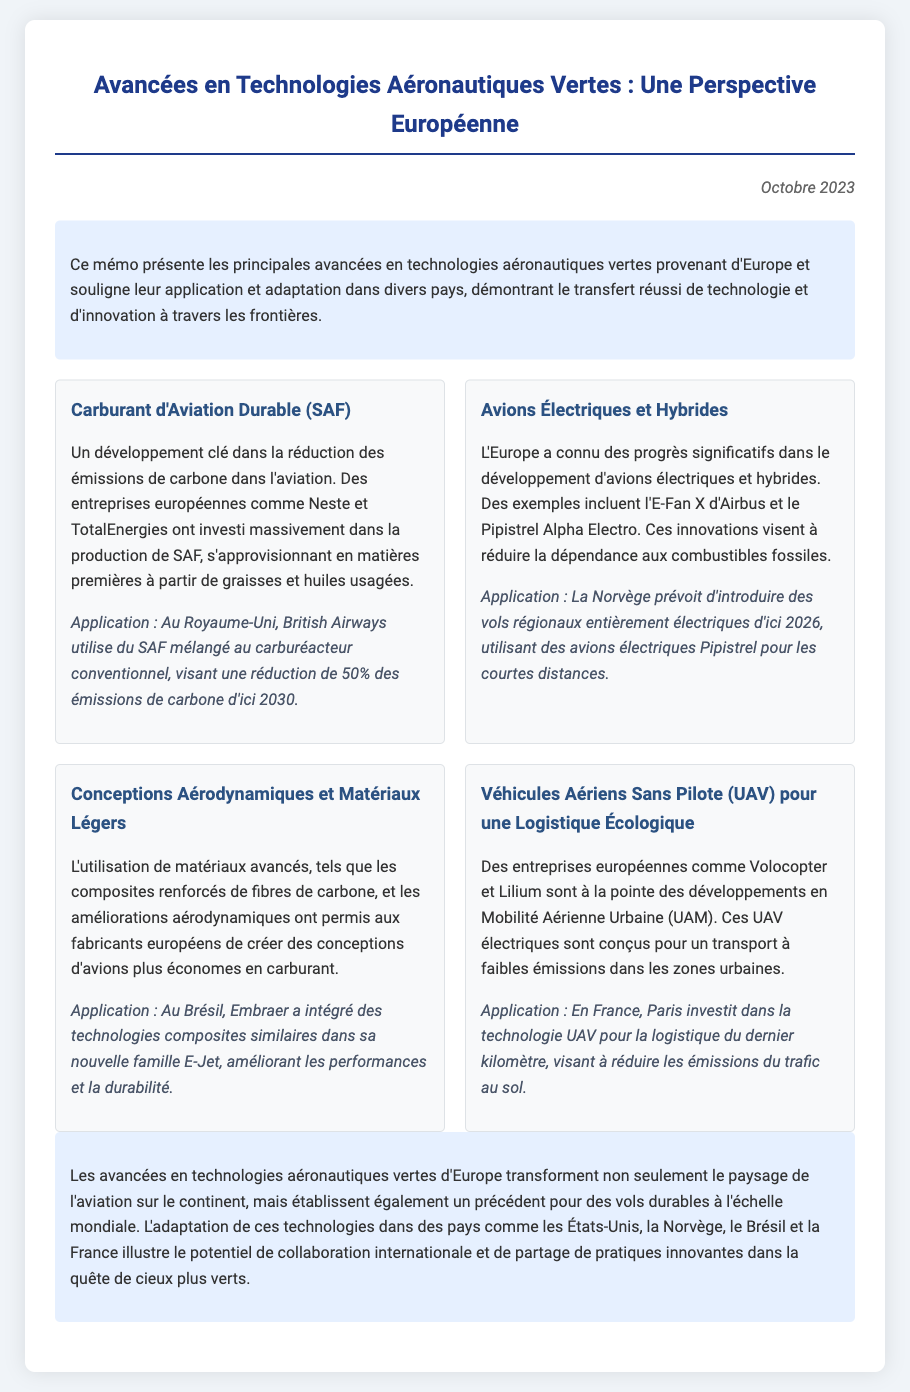Quel est le titre du mémo ? Le titre du mémo est mentionné en haut du document, et il est "Avancées en Technologies Aéronautiques Vertes : Une Perspective Européenne".
Answer: Avancées en Technologies Aéronautiques Vertes : Une Perspective Européenne Quelle entreprise européenne a investi dans la production de carburant d'aviation durable ? La production de carburant d'aviation durable implique des entreprises spécifiques européennes, telles que Neste et TotalEnergies.
Answer: Neste et TotalEnergies Quel est l'objectif de British Airways concernant les émissions de carbone d'ici 2030 ? L'objectif mentionné dans l'application du carburant d'aviation durable est de réduire de 50% les émissions de carbone d'ici 2030.
Answer: 50% Quel type d'avion la Norvège prévoit-elle d'introduire d'ici 2026 ? Le document indique que la Norvège prévoit d'introduire des vols régionaux entièrement électriques.
Answer: Vols régionaux entièrement électriques Comment la France utilise-t-elle la technologie UAV ? L'application de la technologie UAV en France vise à réduire les émissions du trafic au sol.
Answer: Réduire les émissions du trafic au sol Quels matériaux avancés sont mentionnés concernant les conceptions d'avions ? Le mémo évoque l'utilisation de composites renforcés de fibres de carbone comme matériaux avancés.
Answer: Composites renforcés de fibres de carbone Quelle innovation est coordinateur entre les entreprises Volocopter et Lilium ? Le document mentionne que ces entreprises sont à la pointe des développements en Mobilité Aérienne Urbaine.
Answer: Mobilité Aérienne Urbaine Quel est le principal objectif des avancées en technologies aéronautiques vertes ? Le principal objectif mentionné dans la conclusion est de transformer le paysage de l'aviation vers des vols durables à l'échelle mondiale.
Answer: Vols durables à l'échelle mondiale 